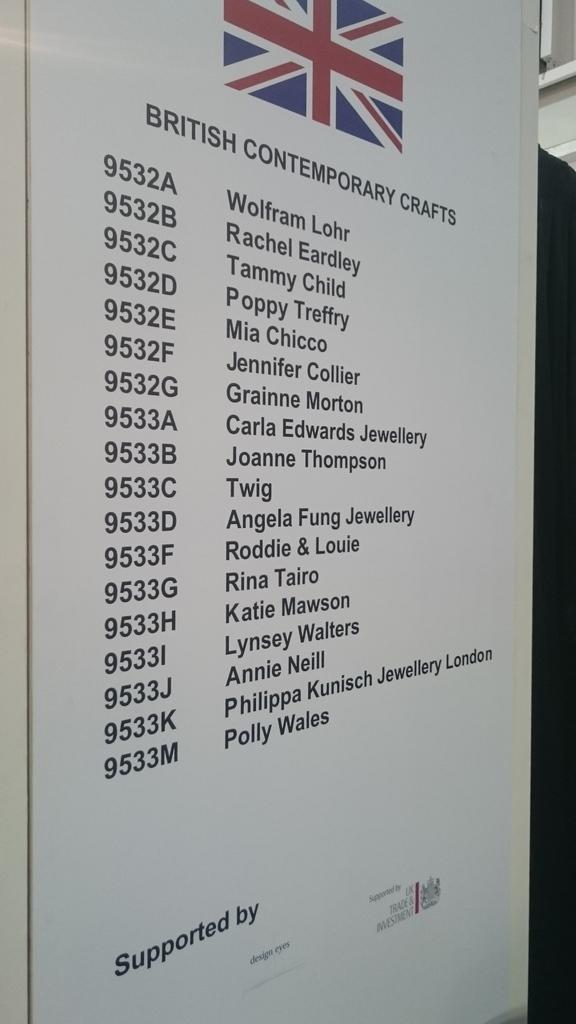<image>
Relay a brief, clear account of the picture shown. Sign showing different names and says "Supported BY" on the bottom. 